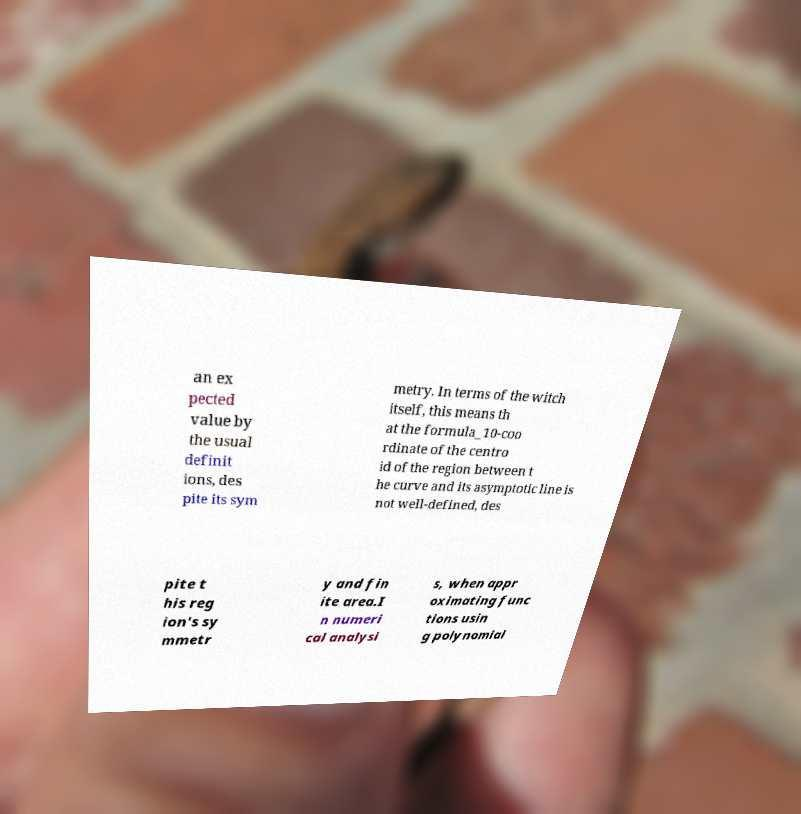There's text embedded in this image that I need extracted. Can you transcribe it verbatim? an ex pected value by the usual definit ions, des pite its sym metry. In terms of the witch itself, this means th at the formula_10-coo rdinate of the centro id of the region between t he curve and its asymptotic line is not well-defined, des pite t his reg ion's sy mmetr y and fin ite area.I n numeri cal analysi s, when appr oximating func tions usin g polynomial 